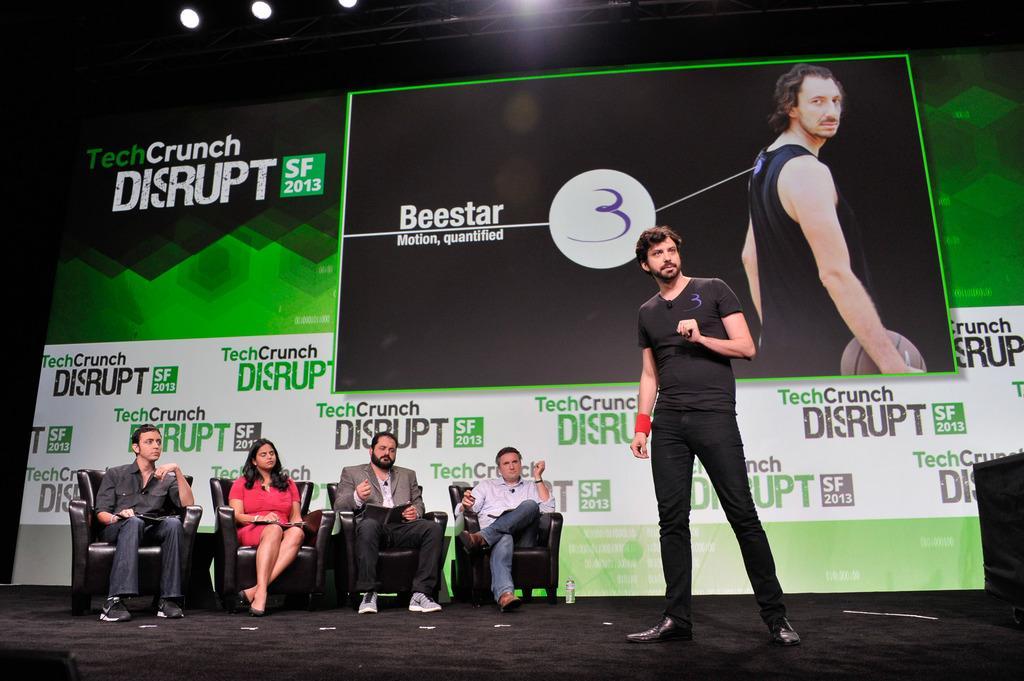Can you describe this image briefly? In this image, there are four persons wearing clothes and sitting on couches. There is a person in the middle of the image standing in front of flex board. 